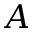Convert formula to latex. <formula><loc_0><loc_0><loc_500><loc_500>A</formula> 